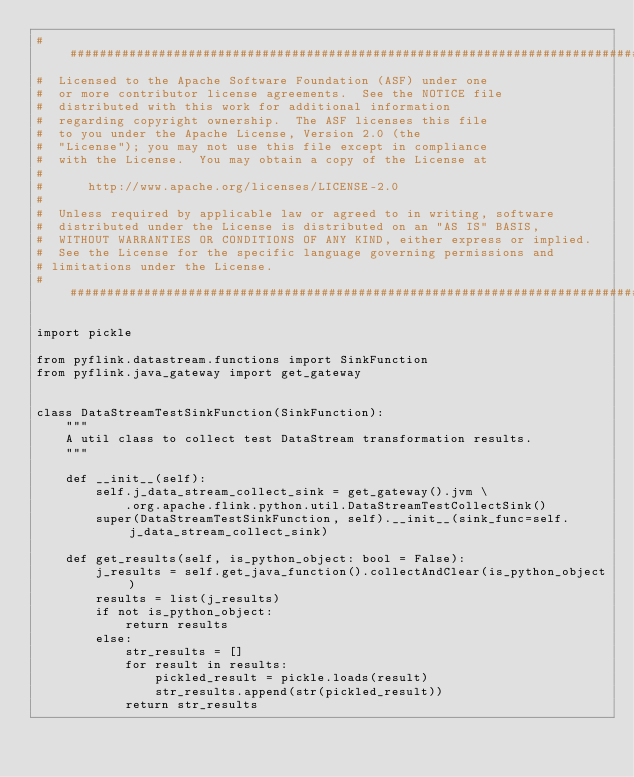Convert code to text. <code><loc_0><loc_0><loc_500><loc_500><_Python_>################################################################################
#  Licensed to the Apache Software Foundation (ASF) under one
#  or more contributor license agreements.  See the NOTICE file
#  distributed with this work for additional information
#  regarding copyright ownership.  The ASF licenses this file
#  to you under the Apache License, Version 2.0 (the
#  "License"); you may not use this file except in compliance
#  with the License.  You may obtain a copy of the License at
#
#      http://www.apache.org/licenses/LICENSE-2.0
#
#  Unless required by applicable law or agreed to in writing, software
#  distributed under the License is distributed on an "AS IS" BASIS,
#  WITHOUT WARRANTIES OR CONDITIONS OF ANY KIND, either express or implied.
#  See the License for the specific language governing permissions and
# limitations under the License.
################################################################################

import pickle

from pyflink.datastream.functions import SinkFunction
from pyflink.java_gateway import get_gateway


class DataStreamTestSinkFunction(SinkFunction):
    """
    A util class to collect test DataStream transformation results.
    """

    def __init__(self):
        self.j_data_stream_collect_sink = get_gateway().jvm \
            .org.apache.flink.python.util.DataStreamTestCollectSink()
        super(DataStreamTestSinkFunction, self).__init__(sink_func=self.j_data_stream_collect_sink)

    def get_results(self, is_python_object: bool = False):
        j_results = self.get_java_function().collectAndClear(is_python_object)
        results = list(j_results)
        if not is_python_object:
            return results
        else:
            str_results = []
            for result in results:
                pickled_result = pickle.loads(result)
                str_results.append(str(pickled_result))
            return str_results
</code> 